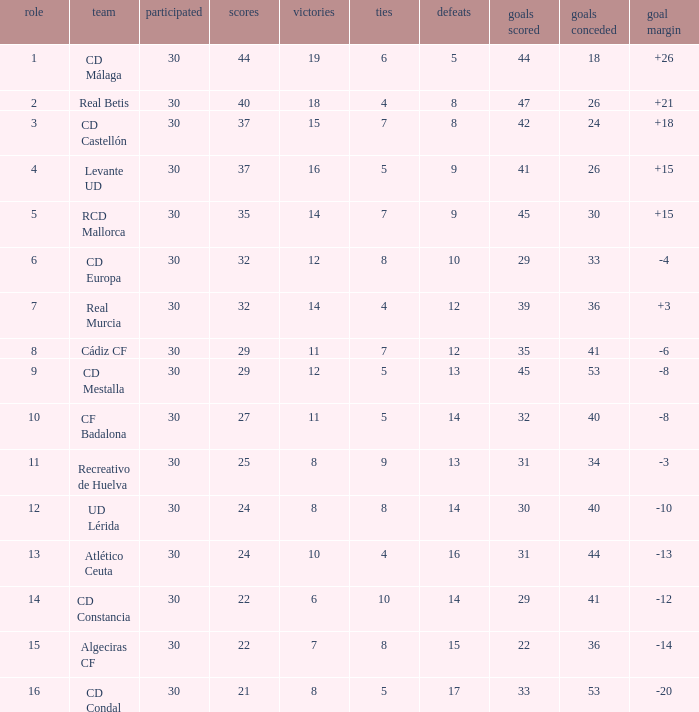What is the goals for when played is larger than 30? None. 